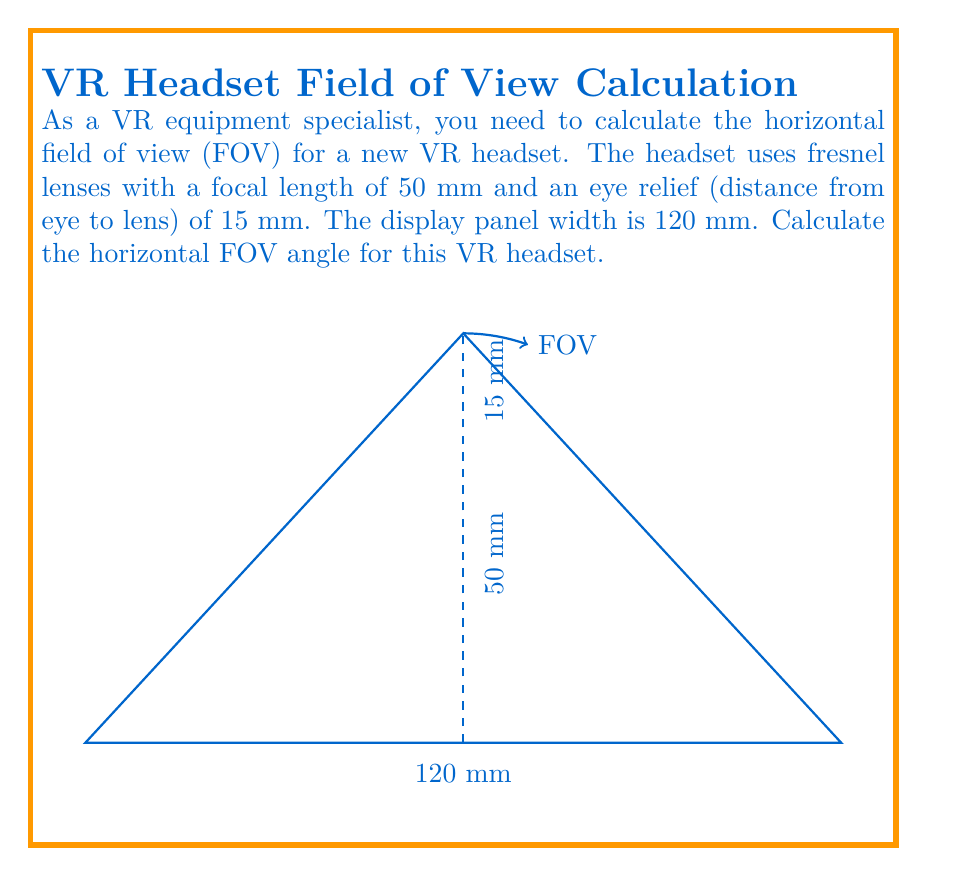Could you help me with this problem? To calculate the horizontal field of view (FOV) for the VR headset, we'll use the following steps:

1. Calculate the total distance from the eye to the display:
   $$d_{total} = \text{focal length} + \text{eye relief} = 50 \text{ mm} + 15 \text{ mm} = 65 \text{ mm}$$

2. Calculate half of the display width:
   $$\frac{\text{display width}}{2} = \frac{120 \text{ mm}}{2} = 60 \text{ mm}$$

3. Use the arctangent function to calculate half of the FOV angle:
   $$\theta_{half} = \arctan\left(\frac{\text{half display width}}{d_{total}}\right) = \arctan\left(\frac{60}{65}\right)$$

4. Calculate the full FOV angle by doubling the result:
   $$\text{FOV} = 2 \times \theta_{half} = 2 \times \arctan\left(\frac{60}{65}\right)$$

5. Convert the result to degrees:
   $$\text{FOV} = 2 \times \arctan\left(\frac{60}{65}\right) \times \frac{180}{\pi} \approx 85.94°$$

Therefore, the horizontal field of view angle for this VR headset is approximately 85.94°.
Answer: $85.94°$ 